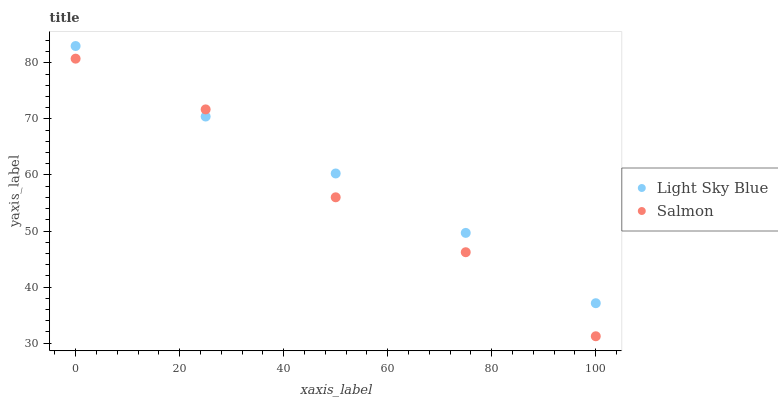Does Salmon have the minimum area under the curve?
Answer yes or no. Yes. Does Light Sky Blue have the maximum area under the curve?
Answer yes or no. Yes. Does Salmon have the maximum area under the curve?
Answer yes or no. No. Is Light Sky Blue the smoothest?
Answer yes or no. Yes. Is Salmon the roughest?
Answer yes or no. Yes. Is Salmon the smoothest?
Answer yes or no. No. Does Salmon have the lowest value?
Answer yes or no. Yes. Does Light Sky Blue have the highest value?
Answer yes or no. Yes. Does Salmon have the highest value?
Answer yes or no. No. Does Salmon intersect Light Sky Blue?
Answer yes or no. Yes. Is Salmon less than Light Sky Blue?
Answer yes or no. No. Is Salmon greater than Light Sky Blue?
Answer yes or no. No. 